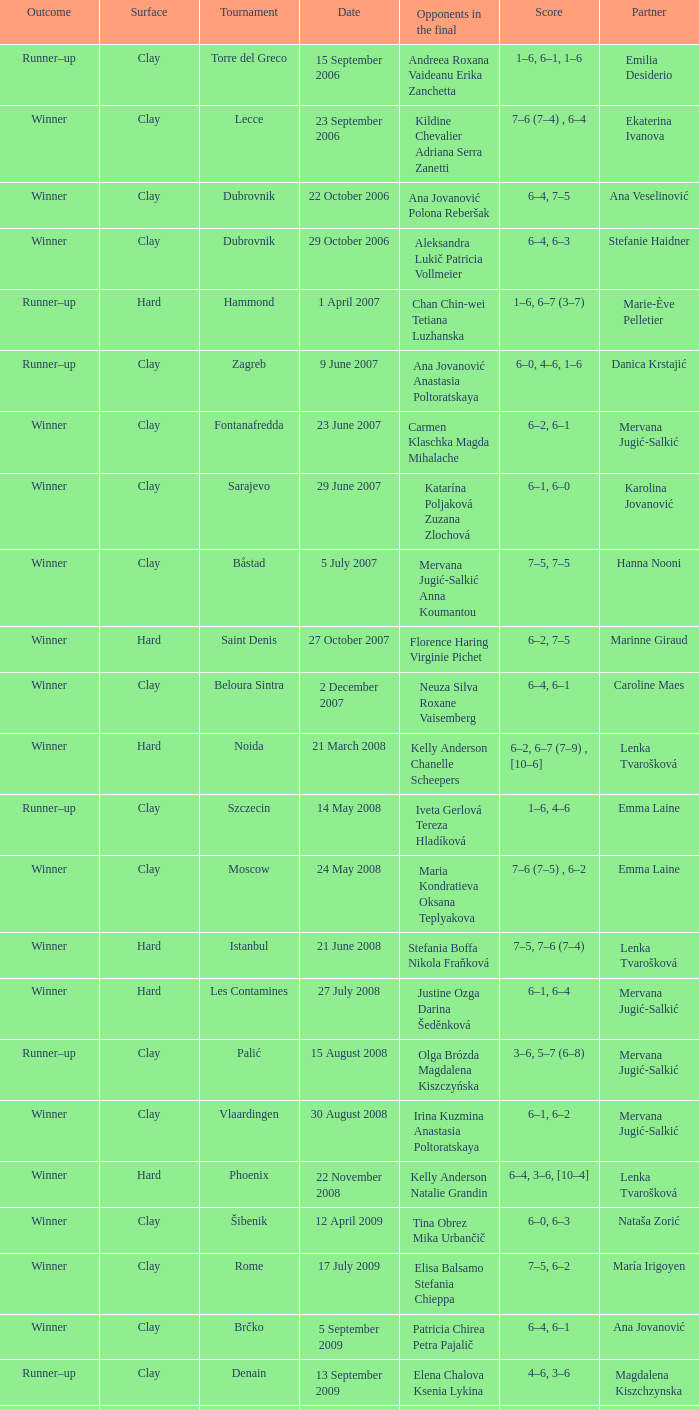Who were the opponents in the final at Noida? Kelly Anderson Chanelle Scheepers. 